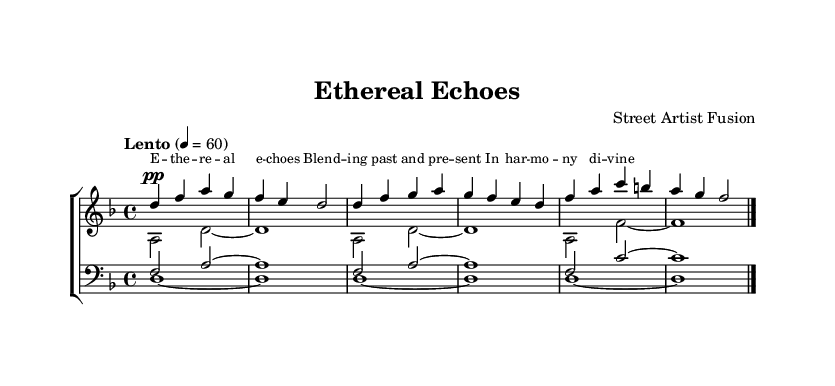What is the key signature of this music? The key signature is indicated by the sharp or flat symbols at the beginning of the staff. In this case, it shows no sharps or flats, which corresponds to D minor.
Answer: D minor What is the time signature of this music? The time signature is found at the beginning of the staff, represented as two numbers stacked vertically. Here, it shows a four over four, indicating 4/4 time.
Answer: 4/4 What is the tempo marking of this music? The tempo marking appears in the score, indicating the speed of the piece. Here, it is specified as "Lento" at a quarter note value of 60 beats per minute.
Answer: Lento, 60 How many vocal parts are there in this sheet music? The number of vocal parts can be counted by looking at the different staves labeled for voices. There are four vocal parts indicated: soprano, alto, tenor, and bass.
Answer: Four Which voice sings the highest notes? To identify the highest voice part, we analyze the ranges of the vocal lines. The soprano voice, which is notated in the upper stave and typically sings the highest pitches, fulfills this role.
Answer: Soprano What is the text of the verse sung in this piece? The lyrics are indicated below the staff lines for the soprano part and begin with "E - the - real echoes." This can be read directly from the score.
Answer: E - the - real echoes 